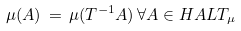Convert formula to latex. <formula><loc_0><loc_0><loc_500><loc_500>\mu ( A ) \, = \, \mu ( T ^ { - 1 } A ) \, \forall A \in H A L T _ { \mu }</formula> 